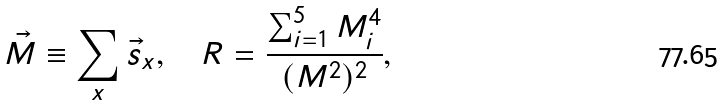<formula> <loc_0><loc_0><loc_500><loc_500>\vec { M } \equiv \sum _ { x } \vec { s } _ { x } , \quad R = \frac { \sum _ { i = 1 } ^ { 5 } M _ { i } ^ { 4 } } { ( M ^ { 2 } ) ^ { 2 } } ,</formula> 